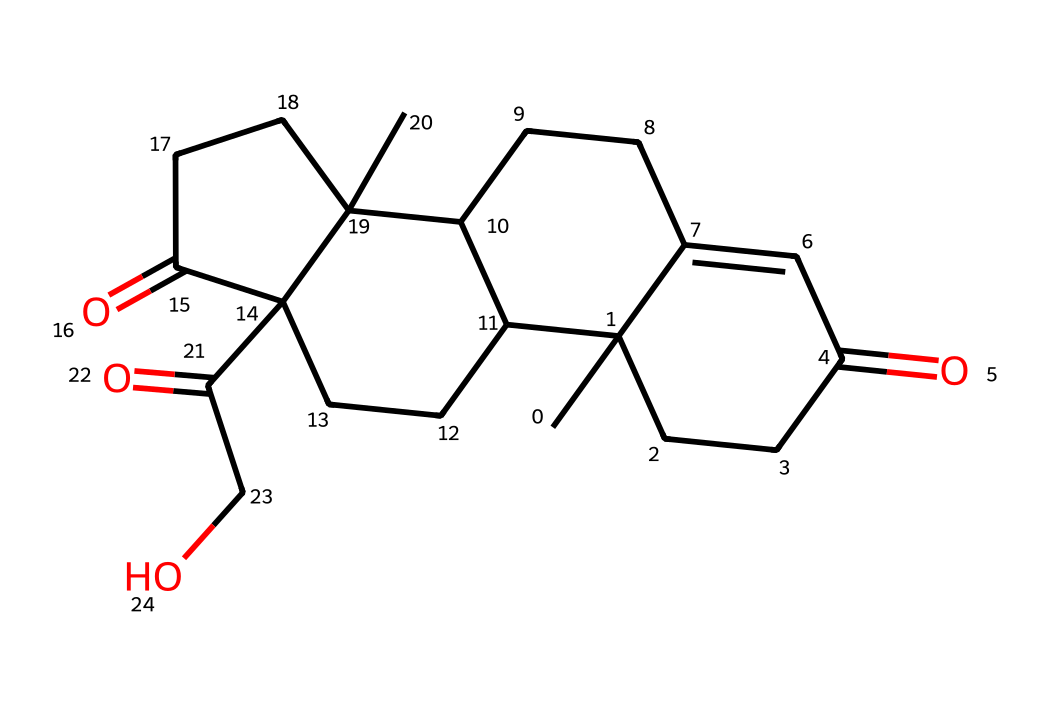What is the molecular formula of cortisol? To find the molecular formula, count the number of atoms of each element in the SMILES representation. For this compound, you will identify 21 carbon (C), 30 hydrogen (H), and 5 oxygen (O) atoms. This gives the formula C21H30O5.
Answer: C21H30O5 How many rings are present in cortisol's structure? By examining the SMILES, identify the presence of cyclic structures. The notation suggests multiple interconnected rings, ultimately leading to four distinct rings within the structure of cortisol.
Answer: 4 What type of functional groups are present in cortisol? Analyze the structure and look for specific groups. In cortisol, you will find ketones (C=O) and hydroxyl (OH) functional groups. This contributes to the hormone's activity.
Answer: ketone and hydroxyl Which part of cortisol contributes to its role as a steroid hormone? Cortisol is classified as a steroid due to its characteristic four-ring structure, a hallmark of steroid hormones. Recognizing this cyclic structure helps in identifying it.
Answer: four-ring structure What does the "stress hormone" cortisol primarily regulate? Cortisol is known to regulate stress responses in the body. Its primary role involves maintaining homeostasis during stress by affecting various metabolic processes.
Answer: stress responses How many carbon atoms in cortisol are part of its ring structures? Count the carbon atoms that are included in the rings by evaluating the cyclic nature of the structure. In cortisol's case, 18 out of 21 carbon atoms are within the ring systems.
Answer: 18 